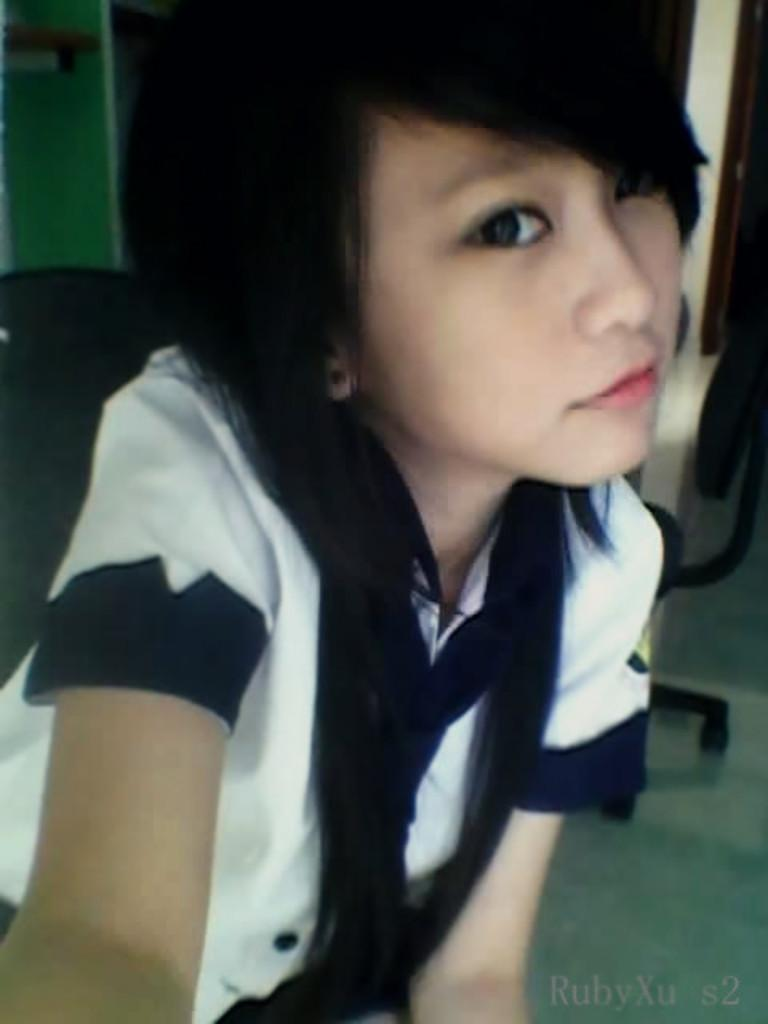Who is the main subject in the image? There is a woman in the image. Can you describe the woman's hair in the image? The woman has loose hair. What is the woman wearing in the image? The woman is wearing a white shirt with a part of blue color. What piece of furniture is visible in the image? There is a chair visible in the image. How is the chair positioned in the image? The chair is partially on the floor surface. What type of yarn is being used to create the wind effect in the image? There is no wind or yarn present in the image; it features a woman with loose hair and a chair partially on the floor surface. 